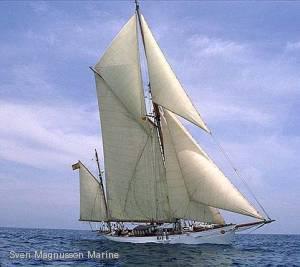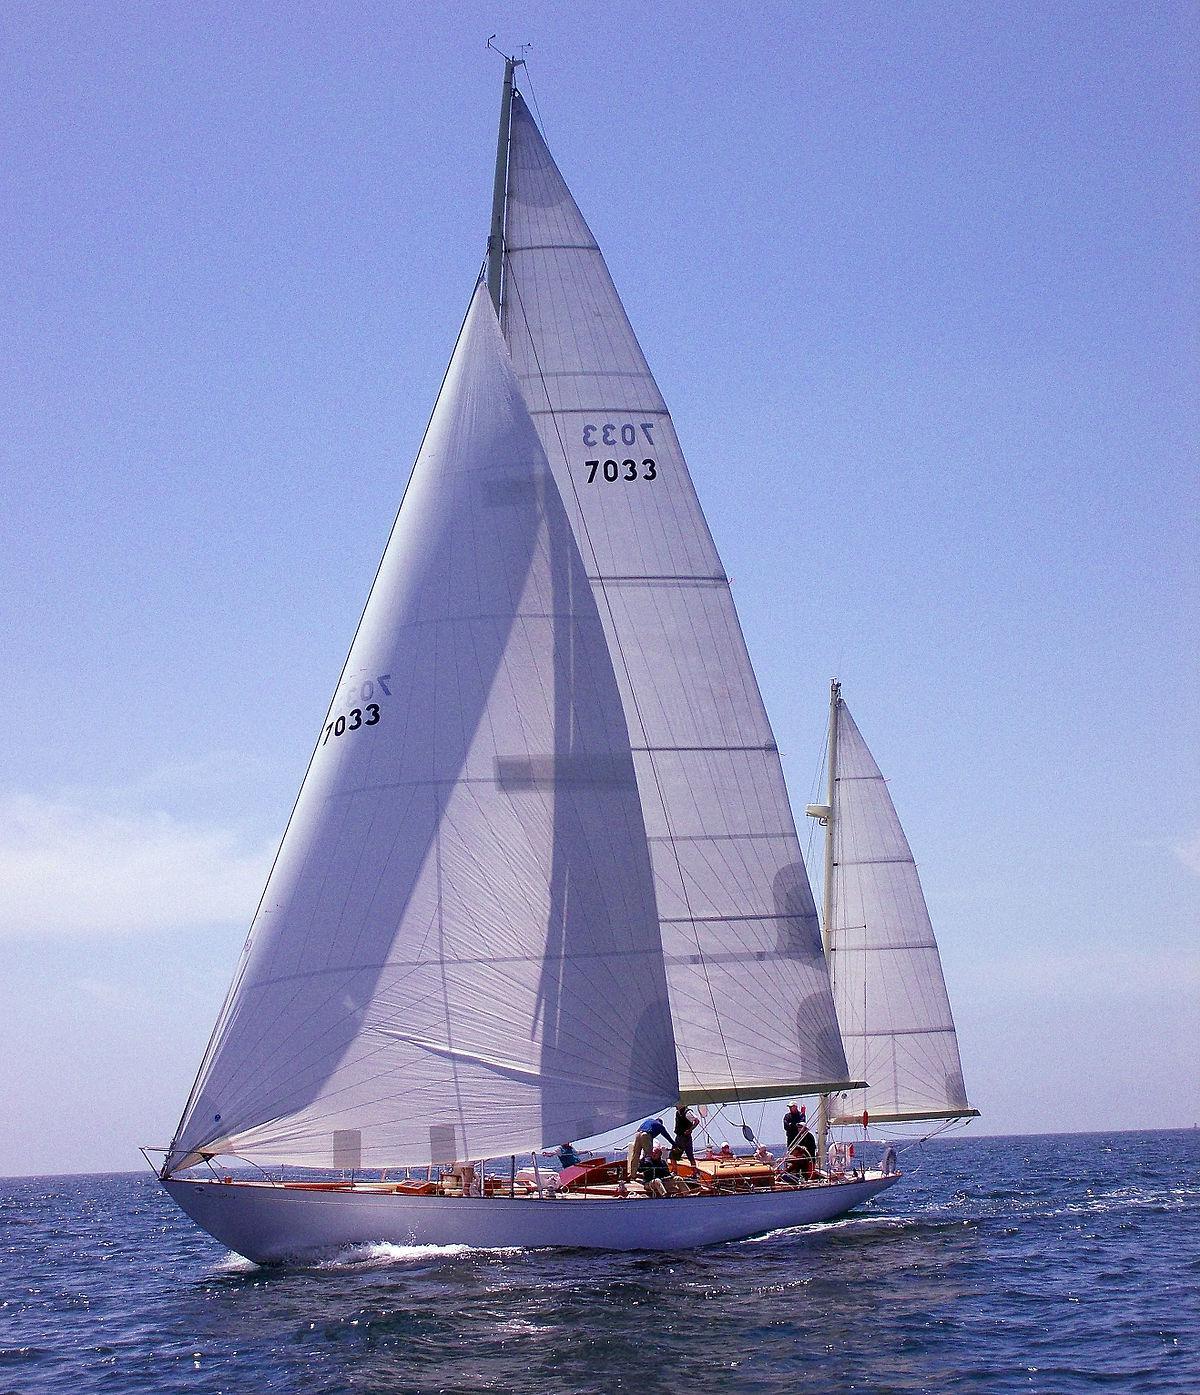The first image is the image on the left, the second image is the image on the right. For the images shown, is this caption "There is a sailboat In water pointing right with a flag displayed flag." true? Answer yes or no. No. 